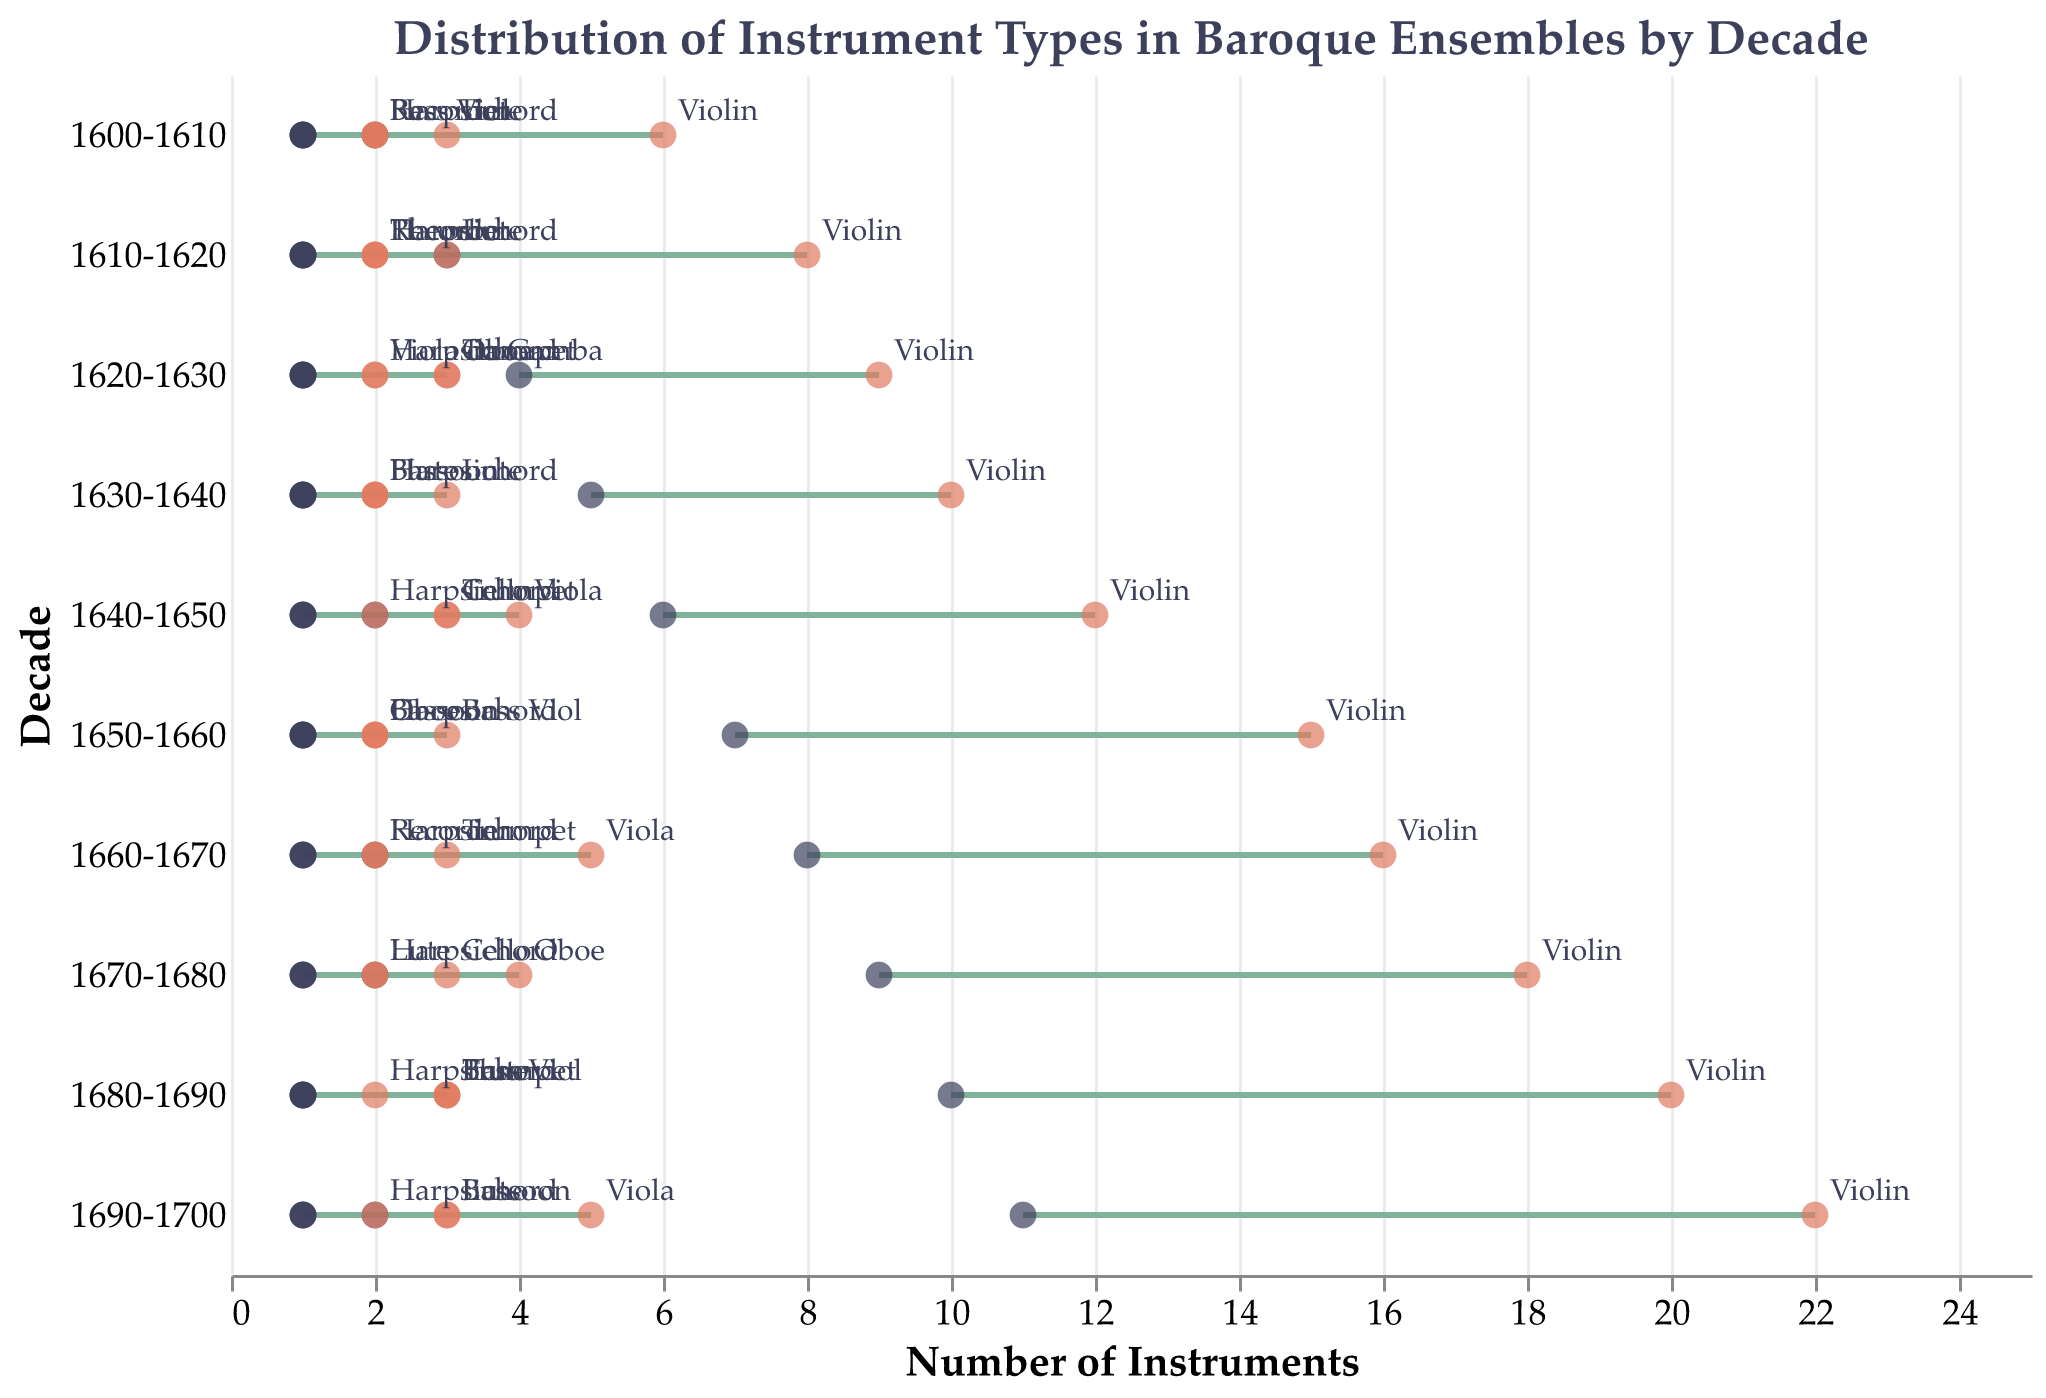What's the title of the figure? The title of the figure is written at the top of the graph. It states, "Distribution of Instrument Types in Baroque Ensembles by Decade."
Answer: Distribution of Instrument Types in Baroque Ensembles by Decade How is the information about the number of instruments displayed in the plot? The number of instruments is shown using ranged dot plots, with points and rules indicating the minimum and maximum counts for each instrument type within a decade.
Answer: Points and rules for minimum and maximum counts Which instrument type had the most significant increase in maximum count from 1600-1610 to 1690-1700? To determine the instrument type with the most significant increase, compare the maximum counts in 1600-1610 and 1690-1700 for each instrument. The violin increased from 6 to 22, the largest increase.
Answer: Violin In which decade did the violin first appear with a minimum count of 8? By observing the minimum counts for the violin across the decades, one can see that the minimum count of 8 first appears in the 1660-1670 decade.
Answer: 1660-1670 What is the range of counts for the harpsichord in every decade? The harpsichord's range remains consistent from 1600-1700. Its minimum count is always 1, and its maximum count is always 2.
Answer: 1 to 2 Out of all instruments listed from 1640 to 1650, which has the highest maximum count? To find the highest maximum count, compare the maximum counts for all instrument types in the 1640-1650 decade. The violin has the highest maximum count with 12.
Answer: Violin How many different instrument types were recorded in the 1630-1640 decade in this plot? By counting the different instrument types listed for the 1630-1640 decade, we see: Violin, Harpsichord, Lute, Bassoon, and Flute, totaling 5 instrument types.
Answer: 5 What is the minimum count of the recorder in the decade 1600-1610? Observing the values for the recorder in the 1600-1610 row, the minimum count for the recorder is listed as 1.
Answer: 1 Which decade shows the maximum count of the trumpet being 3 for the first time? Follow the maximum count of the trumpet across the decades. The decade 1620-1630 is the first to show a maximum count of 3 for the trumpet.
Answer: 1620-1630 How does the range of the oboe's counts change between 1620-1630 and 1670-1680? Comparing the counts, in 1620-1630, the oboe has a range of 1 to 3. In 1670-1680, the range is 2 to 4. This indicates both the minimum and maximum counts increased by 1.
Answer: Minimum increased by 1, Maximum increased by 1 